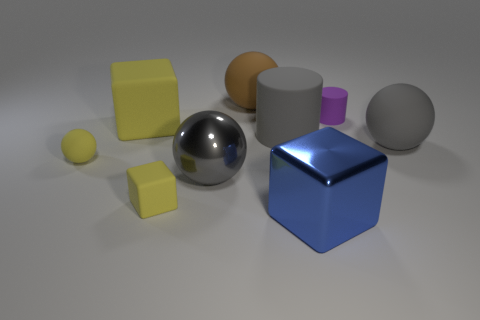There is a blue object that is the same shape as the big yellow rubber thing; what is its material? metal 